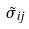Convert formula to latex. <formula><loc_0><loc_0><loc_500><loc_500>\tilde { \sigma } _ { i j }</formula> 